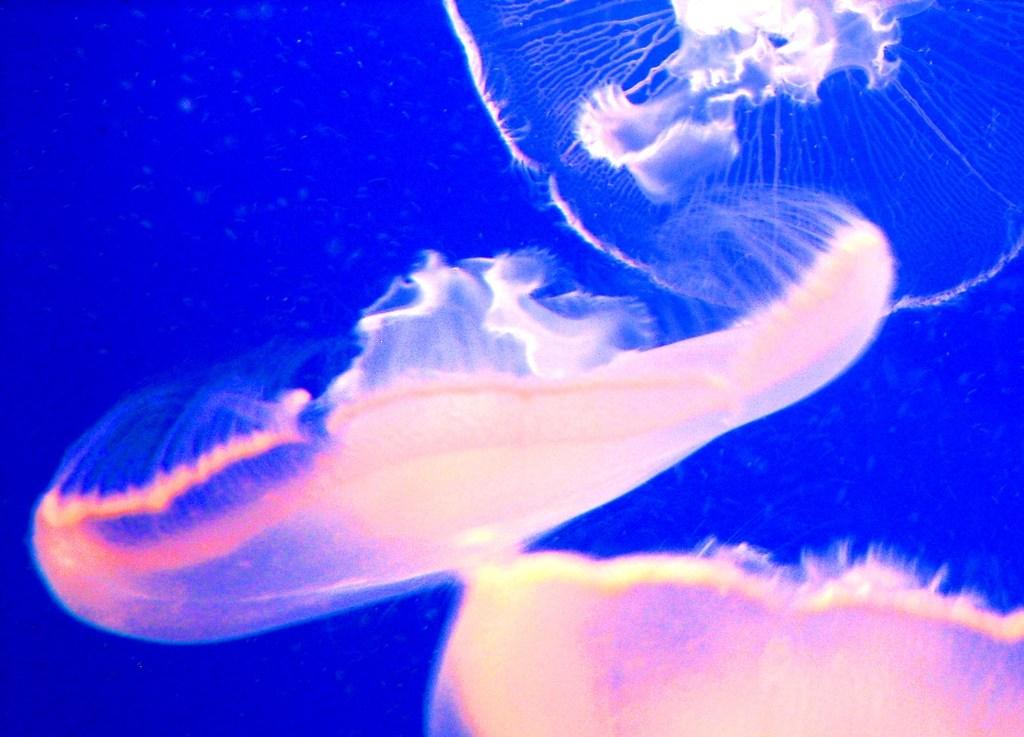What type of animals are in the image? There are two white jellyfish in the image. Where are the jellyfish located? The jellyfish are in the sea water. What color is the background of the image? The background of the image is blue. How does the hand express hate towards the jellyfish in the image? There is no hand or expression of hate present in the image; it features two white jellyfish in the sea water with a blue background. 